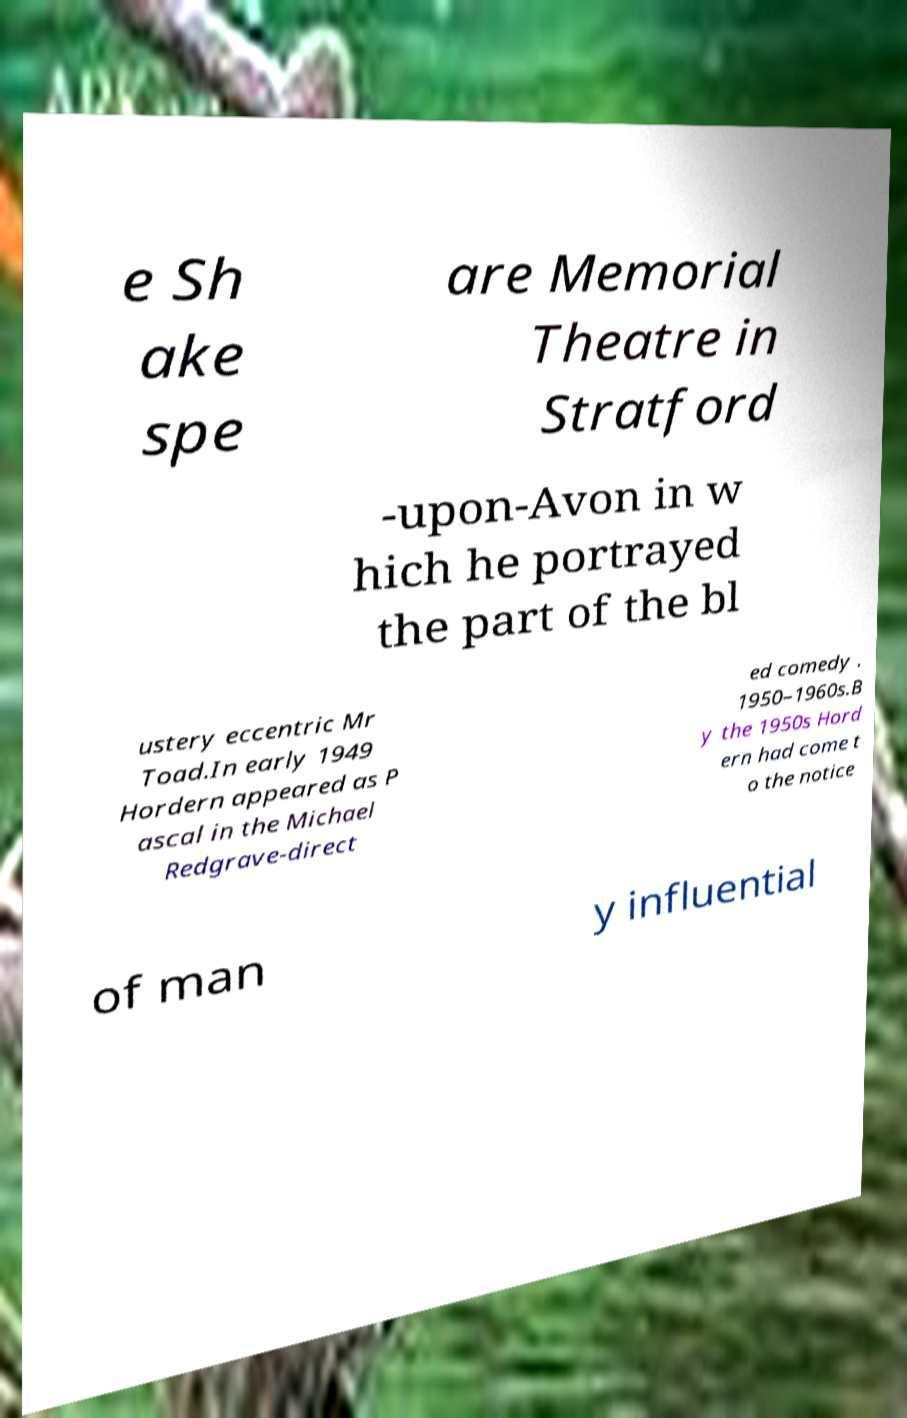Can you accurately transcribe the text from the provided image for me? e Sh ake spe are Memorial Theatre in Stratford -upon-Avon in w hich he portrayed the part of the bl ustery eccentric Mr Toad.In early 1949 Hordern appeared as P ascal in the Michael Redgrave-direct ed comedy . 1950–1960s.B y the 1950s Hord ern had come t o the notice of man y influential 